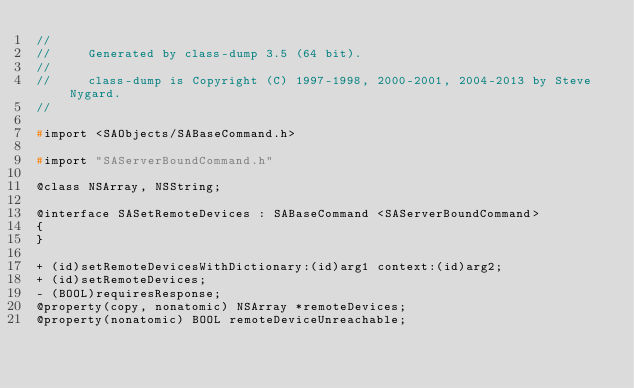Convert code to text. <code><loc_0><loc_0><loc_500><loc_500><_C_>//
//     Generated by class-dump 3.5 (64 bit).
//
//     class-dump is Copyright (C) 1997-1998, 2000-2001, 2004-2013 by Steve Nygard.
//

#import <SAObjects/SABaseCommand.h>

#import "SAServerBoundCommand.h"

@class NSArray, NSString;

@interface SASetRemoteDevices : SABaseCommand <SAServerBoundCommand>
{
}

+ (id)setRemoteDevicesWithDictionary:(id)arg1 context:(id)arg2;
+ (id)setRemoteDevices;
- (BOOL)requiresResponse;
@property(copy, nonatomic) NSArray *remoteDevices;
@property(nonatomic) BOOL remoteDeviceUnreachable;</code> 